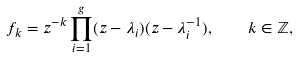Convert formula to latex. <formula><loc_0><loc_0><loc_500><loc_500>f _ { k } = z ^ { - k } \prod _ { i = 1 } ^ { g } ( z - \lambda _ { i } ) ( z - \lambda _ { i } ^ { - 1 } ) , \quad k \in \mathbb { Z } ,</formula> 